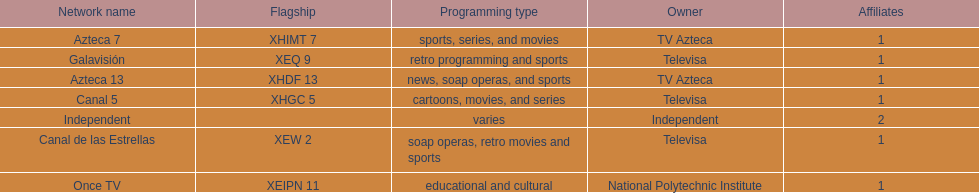Who is the only network owner listed in a consecutive order in the chart? Televisa. 